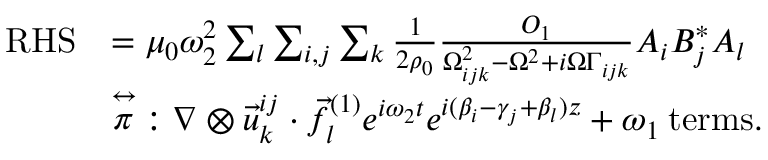Convert formula to latex. <formula><loc_0><loc_0><loc_500><loc_500>\begin{array} { r l } { R H S } & { = \mu _ { 0 } \omega _ { 2 } ^ { 2 } \sum _ { l } \sum _ { i , j } \sum _ { k } \frac { 1 } { 2 \rho _ { 0 } } \frac { O _ { 1 } } { \Omega _ { i j k } ^ { 2 } - \Omega ^ { 2 } + i \Omega \Gamma _ { i j k } } A _ { i } B _ { j } ^ { * } A _ { l } } \\ & { { \stackrel { \leftrightarrow } { \pi } } \colon \nabla \otimes \vec { u } _ { k } ^ { i j } \cdot \vec { f } _ { l } ^ { ( 1 ) } e ^ { i \omega _ { 2 } t } e ^ { i ( \beta _ { i } - \gamma _ { j } + \beta _ { l } ) z } + \omega _ { 1 } \, { t e r m s } . } \end{array}</formula> 